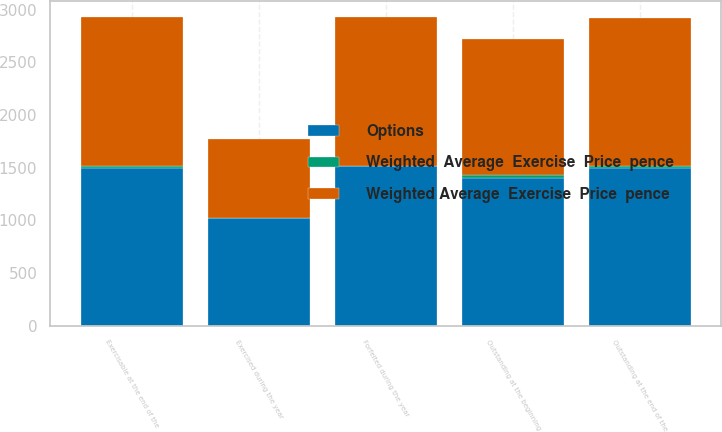Convert chart. <chart><loc_0><loc_0><loc_500><loc_500><stacked_bar_chart><ecel><fcel>Outstanding at the beginning<fcel>Forfeited during the year<fcel>Exercised during the year<fcel>Outstanding at the end of the<fcel>Exercisable at the end of the<nl><fcel>Weighted  Average  Exercise  Price  pence<fcel>23.1<fcel>2.1<fcel>4.6<fcel>16.4<fcel>16.4<nl><fcel>Options<fcel>1406<fcel>1514.59<fcel>1019.94<fcel>1498.75<fcel>1498.75<nl><fcel>Weighted Average  Exercise  Price  pence<fcel>1296.72<fcel>1419.28<fcel>750.17<fcel>1405.79<fcel>1415.63<nl></chart> 